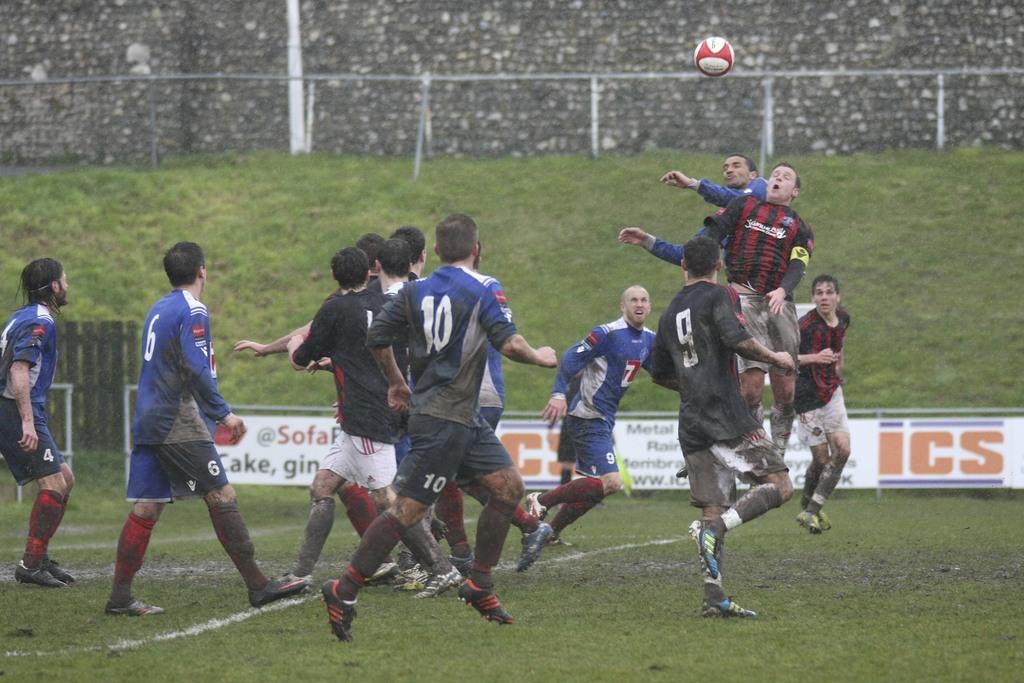What number is either of the players on the field?
Provide a short and direct response. 10. What letters are on the banner behind the players?
Your response must be concise. Ics. 